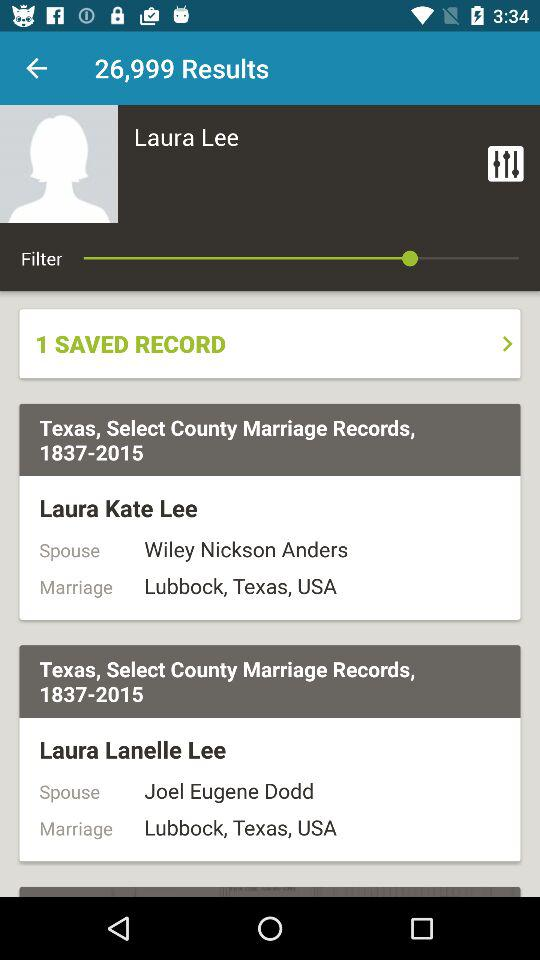How many Laura Lee records are there?
Answer the question using a single word or phrase. 2 